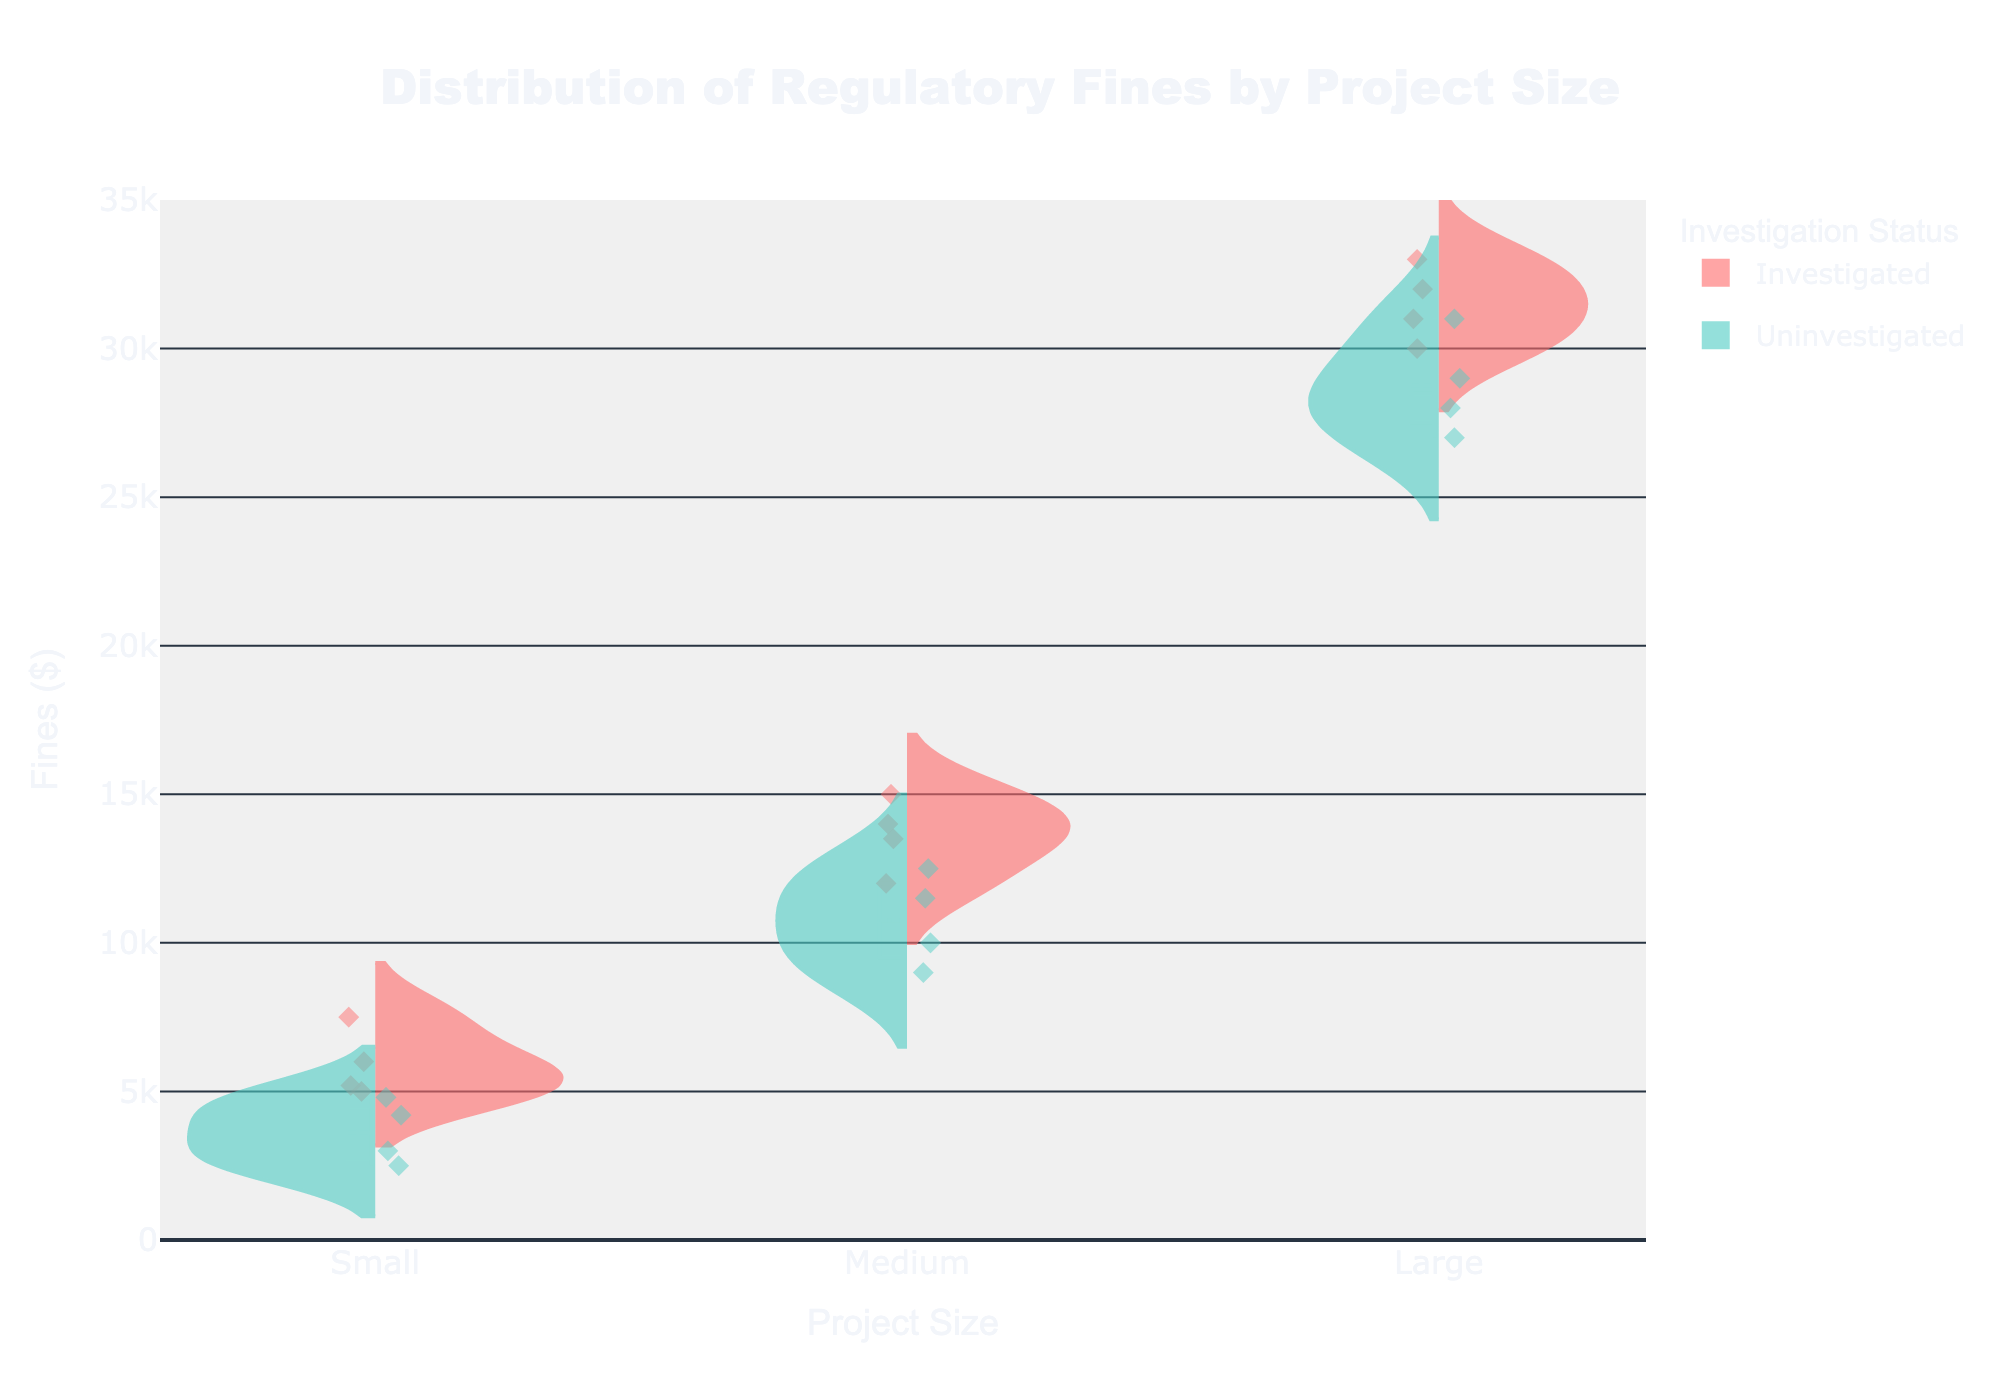what is the title of the figure? The title is located at the top of the figure. It states the main topic or purpose of the visualization, which is 'Distribution of Regulatory Fines by Project Size'.
Answer: Distribution of Regulatory Fines by Project Size What is the range of fines displayed on the Y-axis? The Y-axis represents the fines, and it ranges from 0 to 35000 as indicated by the ticks on the Y-axis.
Answer: 0 to 35000 Which project size category has the highest box plot mean line for investigated fines? By observing the box plot mean lines within each category for investigated fines (positive side of the violin), the 'Large' project size shows the highest mean line compared to 'Small' and 'Medium'.
Answer: Large How many total data points are there for uninvestigated fines in small project sizes? There are four data points displayed as diamond markers within the 'Small' category on the negative side of the violin plot, representing uninvestigated fines.
Answer: 4 What is the median investigated fine for medium-sized projects? The median is represented by the line inside the box plot on the positive side of the violin for medium-sized projects. By observing this line, the median investigated fine is halfway between the 12000 and 15000 marks.
Answer: 13500 What's the difference between the maximum investigated fine and maximum uninvestigated fine for large projects? For large projects, the highest investigated fine is 33000, and the highest uninvestigated fine is 31000. The difference is 33000 - 31000.
Answer: 2000 Which project size has more variability in investigated fines? Variability can be assessed by looking at the width and spread of the violin plot on the positive side for each project size. 'Large' project sizes show the widest spread indicating the most variability.
Answer: Large Are uninvestigated fines generally lower than investigated fines for medium projects? By comparing the general spread and median lines of the uninvestigated fines (negative side) and investigated fines (positive side) within the 'Medium' category, it's evident that uninvestigated fines are generally lower.
Answer: Yes What is the mean of uninvestigated fines for small projects? By averaging the uninvestigated fines for small projects: (3000 + 4200 + 2500 + 4800)/4, we get the mean.
Answer: 3625 Considering both sides, which project size category displays the greatest overlap between investigated and uninvestigated fines? Overlap is best observed by the middle section of the violin plots for both sides. 'Medium' project sizes have the greatest overlap, as their distributions visibly intersect more than the small or large categories.
Answer: Medium 